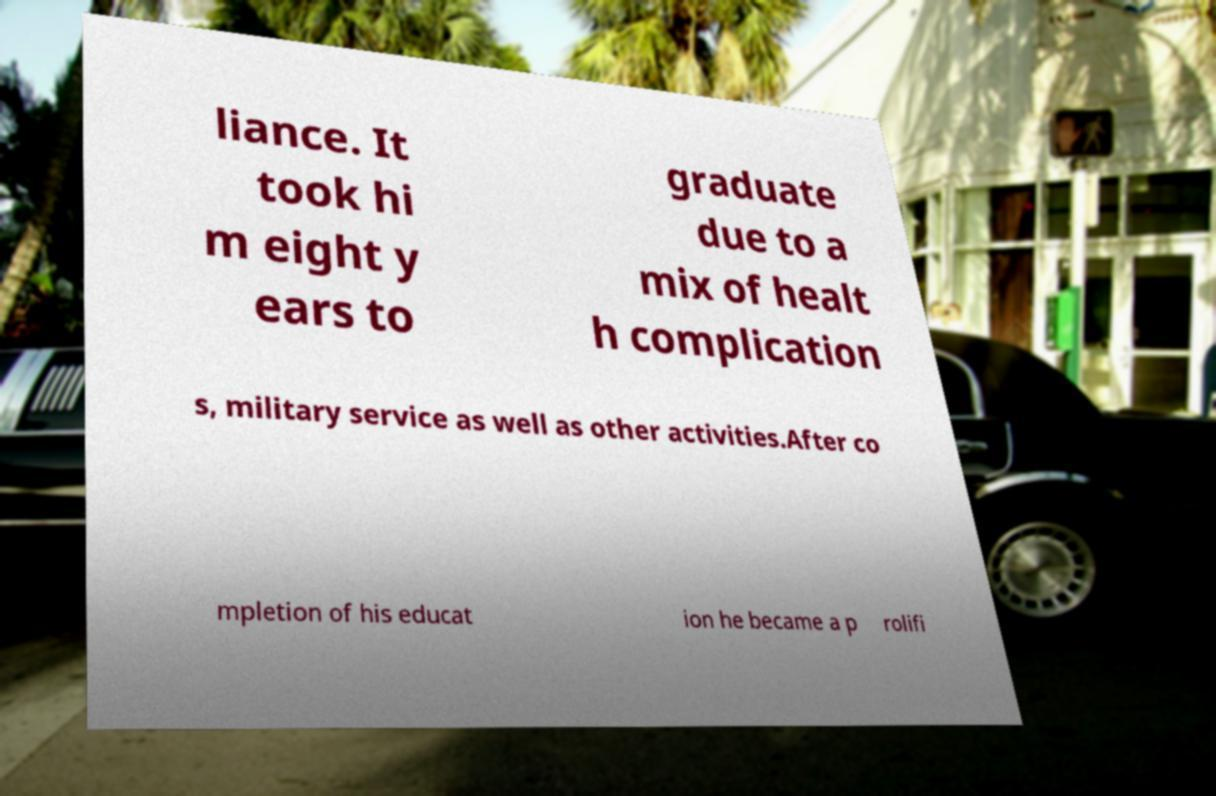There's text embedded in this image that I need extracted. Can you transcribe it verbatim? liance. It took hi m eight y ears to graduate due to a mix of healt h complication s, military service as well as other activities.After co mpletion of his educat ion he became a p rolifi 